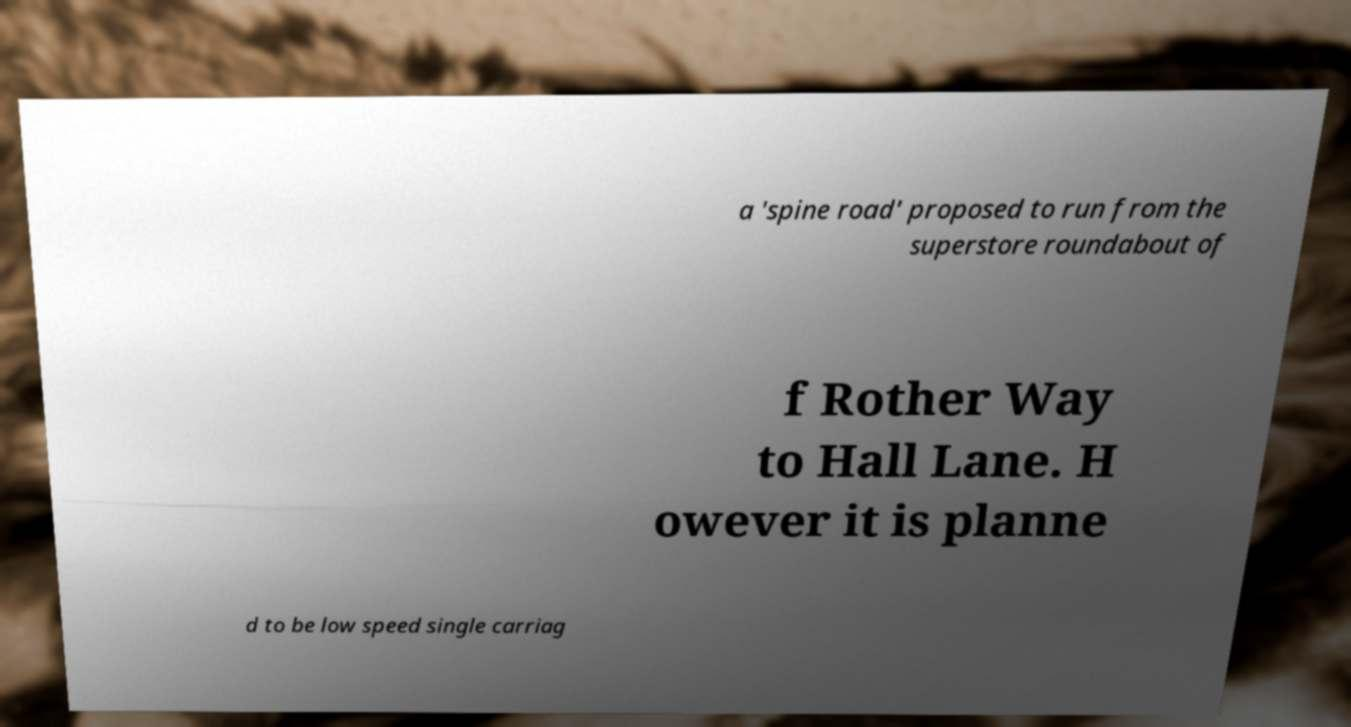There's text embedded in this image that I need extracted. Can you transcribe it verbatim? a 'spine road' proposed to run from the superstore roundabout of f Rother Way to Hall Lane. H owever it is planne d to be low speed single carriag 